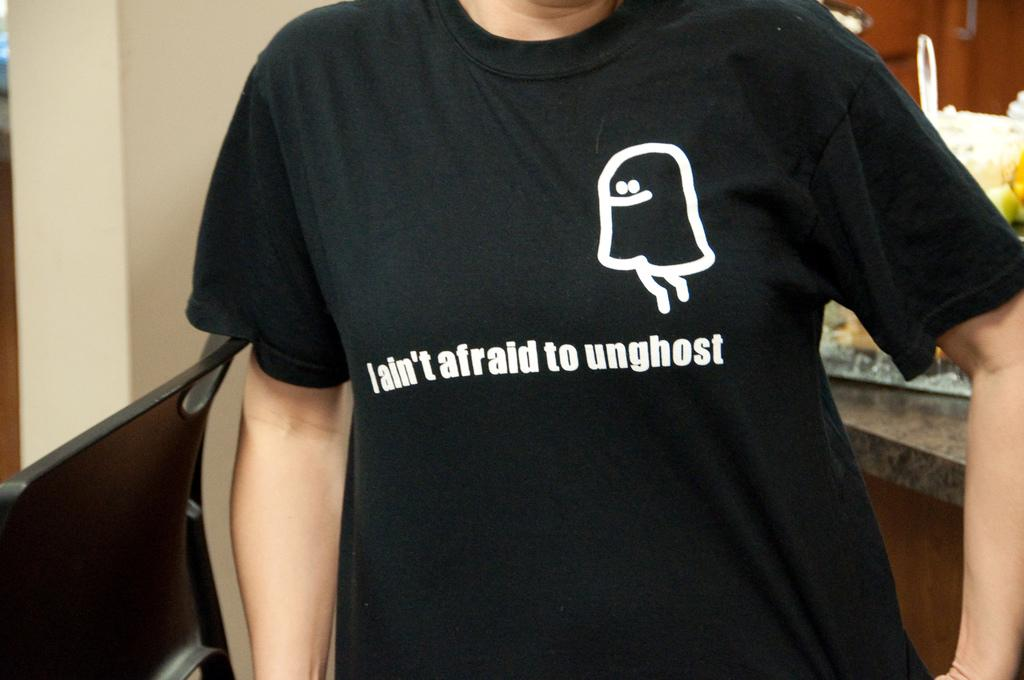<image>
Share a concise interpretation of the image provided. a character on a shirt with the word unghost on it 